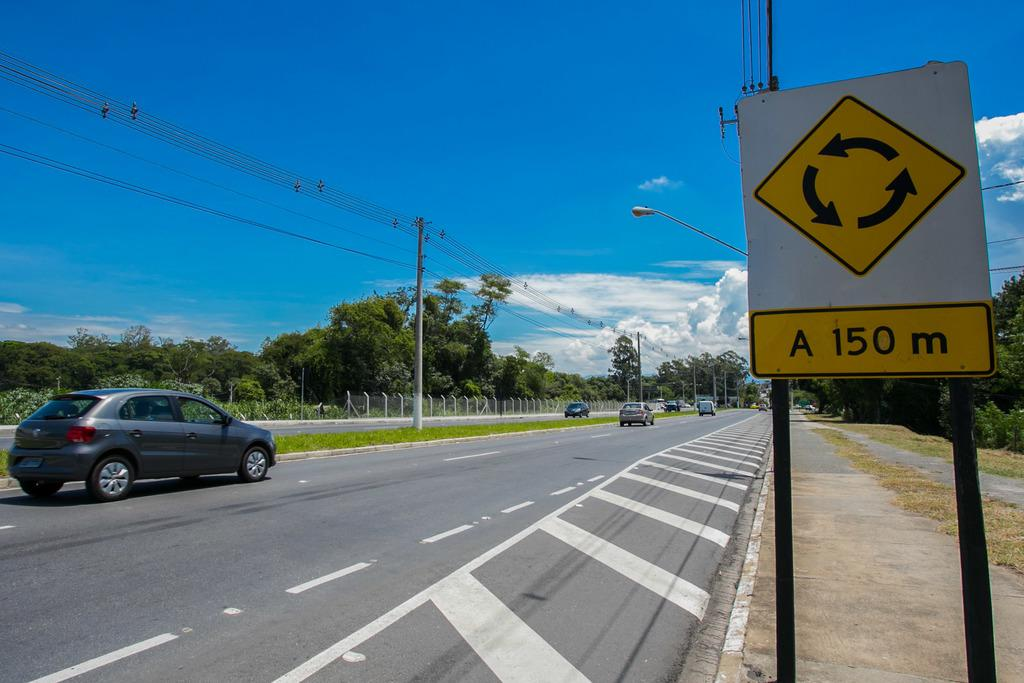<image>
Offer a succinct explanation of the picture presented. a sign that has the number 150 on it 